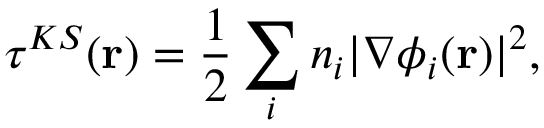<formula> <loc_0><loc_0><loc_500><loc_500>\tau ^ { K S } ( r ) = \frac { 1 } { 2 } \sum _ { i } n _ { i } | \nabla \phi _ { i } ( r ) | ^ { 2 } ,</formula> 